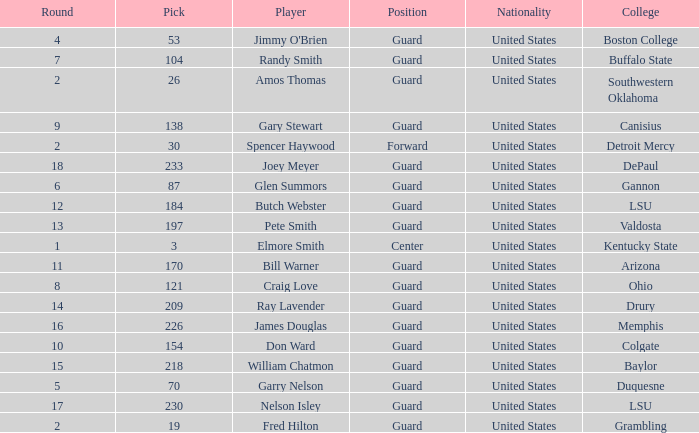WHAT POSITION HAS A ROUND LARGER THAN 2, FOR VALDOSTA COLLEGE? Guard. Write the full table. {'header': ['Round', 'Pick', 'Player', 'Position', 'Nationality', 'College'], 'rows': [['4', '53', "Jimmy O'Brien", 'Guard', 'United States', 'Boston College'], ['7', '104', 'Randy Smith', 'Guard', 'United States', 'Buffalo State'], ['2', '26', 'Amos Thomas', 'Guard', 'United States', 'Southwestern Oklahoma'], ['9', '138', 'Gary Stewart', 'Guard', 'United States', 'Canisius'], ['2', '30', 'Spencer Haywood', 'Forward', 'United States', 'Detroit Mercy'], ['18', '233', 'Joey Meyer', 'Guard', 'United States', 'DePaul'], ['6', '87', 'Glen Summors', 'Guard', 'United States', 'Gannon'], ['12', '184', 'Butch Webster', 'Guard', 'United States', 'LSU'], ['13', '197', 'Pete Smith', 'Guard', 'United States', 'Valdosta'], ['1', '3', 'Elmore Smith', 'Center', 'United States', 'Kentucky State'], ['11', '170', 'Bill Warner', 'Guard', 'United States', 'Arizona'], ['8', '121', 'Craig Love', 'Guard', 'United States', 'Ohio'], ['14', '209', 'Ray Lavender', 'Guard', 'United States', 'Drury'], ['16', '226', 'James Douglas', 'Guard', 'United States', 'Memphis'], ['10', '154', 'Don Ward', 'Guard', 'United States', 'Colgate'], ['15', '218', 'William Chatmon', 'Guard', 'United States', 'Baylor'], ['5', '70', 'Garry Nelson', 'Guard', 'United States', 'Duquesne'], ['17', '230', 'Nelson Isley', 'Guard', 'United States', 'LSU'], ['2', '19', 'Fred Hilton', 'Guard', 'United States', 'Grambling']]} 